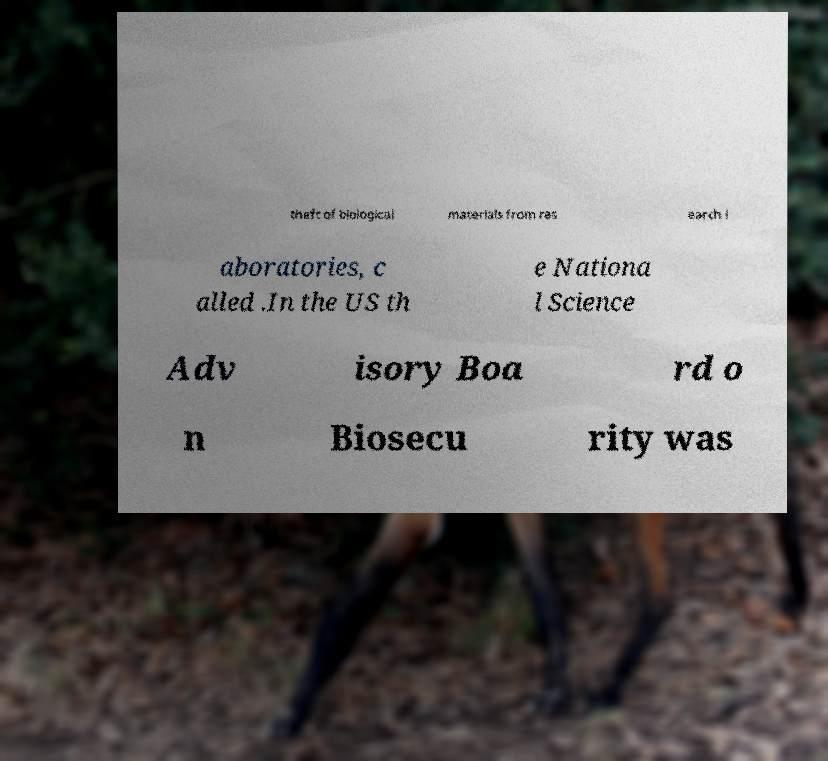Can you accurately transcribe the text from the provided image for me? theft of biological materials from res earch l aboratories, c alled .In the US th e Nationa l Science Adv isory Boa rd o n Biosecu rity was 